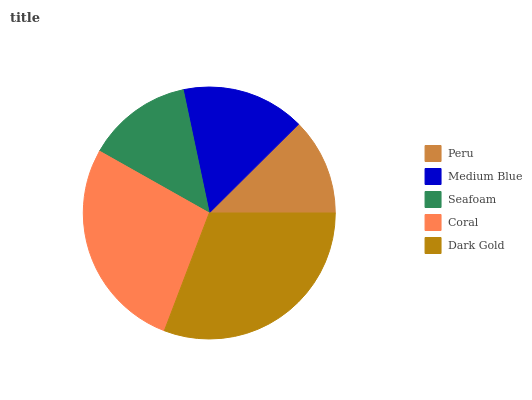Is Peru the minimum?
Answer yes or no. Yes. Is Dark Gold the maximum?
Answer yes or no. Yes. Is Medium Blue the minimum?
Answer yes or no. No. Is Medium Blue the maximum?
Answer yes or no. No. Is Medium Blue greater than Peru?
Answer yes or no. Yes. Is Peru less than Medium Blue?
Answer yes or no. Yes. Is Peru greater than Medium Blue?
Answer yes or no. No. Is Medium Blue less than Peru?
Answer yes or no. No. Is Medium Blue the high median?
Answer yes or no. Yes. Is Medium Blue the low median?
Answer yes or no. Yes. Is Peru the high median?
Answer yes or no. No. Is Seafoam the low median?
Answer yes or no. No. 